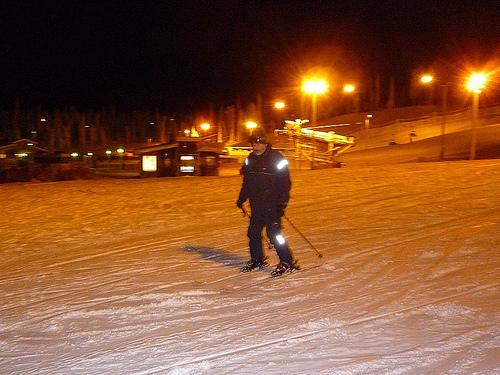Explain the role of shadows and reflections in the image. Shadows are cast by the person and other objects due to the street lights, while the reflections come from the man's clothing and are visible on his shoulder and knee. Mention the types of lighting in the image and their sources. There are bright orange lights from street lamps on tall poles and the illuminated windows of a building, as well as reflective lights on the man's shoulder and knee. How many people are in the image, and what is unique about their attire? There is one person in the image who is wearing a dark blue ski suit with reflective material on the shoulders and a black hat. Describe the overall scene of the image in detail. The image shows a man with a beard skiing on a snowy field at night, wearing reflective clothing, and leaving ski tracks in the snow. Nearby are a small wooden building, pole-mounted street lights, and a snow spreading machine. The night sky is dark and clear. Enumerate the key objects and their interaction with the person in the image. Key objects include ski poles, ski boots, a snow-spreading machine, pole-mounted lights, and a wooden building. The person holds the ski poles, wears the boots, and is skiing near the other objects. Explain the weather condition and time of day in the image. The image was captured at night during winter, as thick snow covers the ground and the sky is black. Analyze the mood or emotion conveyed by the image. The mood of the image is serene and peaceful, as a solitary man skis at night surrounded by the quiet beauty of a snow-covered landscape with gentle lighting. Comment on the image's quality in terms of clarity and focus. The image has good clarity and focus, with clear distinctions between objects, well-defined shadows, visible ski tracks, and detailed features such as the man's beard and reflections on his clothes. Count the number of buildings and describe their appearance briefly. There are two buildings in the image: a small wooden building with illuminated windows and a smaller wooden shed. 